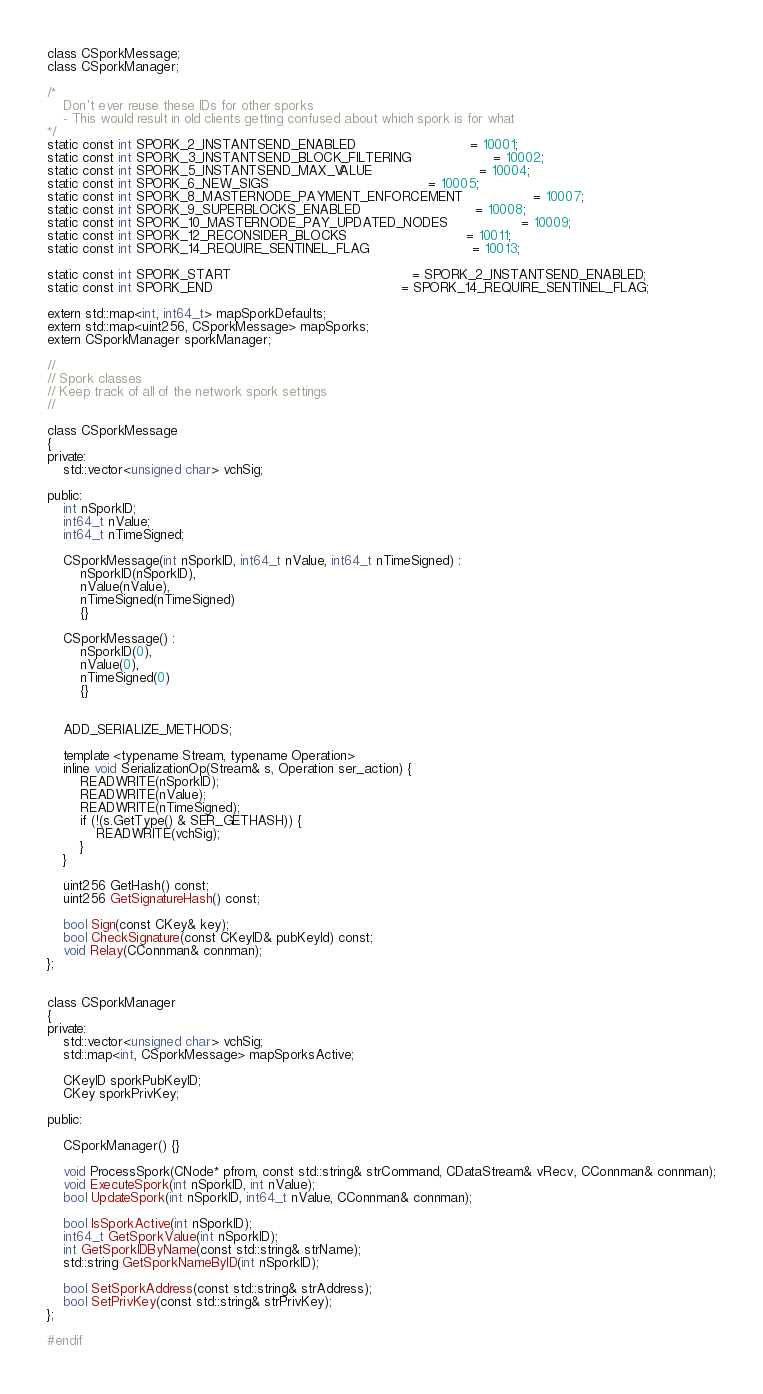<code> <loc_0><loc_0><loc_500><loc_500><_C_>class CSporkMessage;
class CSporkManager;

/*
    Don't ever reuse these IDs for other sporks
    - This would result in old clients getting confused about which spork is for what
*/
static const int SPORK_2_INSTANTSEND_ENABLED                            = 10001;
static const int SPORK_3_INSTANTSEND_BLOCK_FILTERING                    = 10002;
static const int SPORK_5_INSTANTSEND_MAX_VALUE                          = 10004;
static const int SPORK_6_NEW_SIGS                                       = 10005;
static const int SPORK_8_MASTERNODE_PAYMENT_ENFORCEMENT                 = 10007;
static const int SPORK_9_SUPERBLOCKS_ENABLED                            = 10008;
static const int SPORK_10_MASTERNODE_PAY_UPDATED_NODES                  = 10009;
static const int SPORK_12_RECONSIDER_BLOCKS                             = 10011;
static const int SPORK_14_REQUIRE_SENTINEL_FLAG                         = 10013;

static const int SPORK_START                                            = SPORK_2_INSTANTSEND_ENABLED;
static const int SPORK_END                                              = SPORK_14_REQUIRE_SENTINEL_FLAG;

extern std::map<int, int64_t> mapSporkDefaults;
extern std::map<uint256, CSporkMessage> mapSporks;
extern CSporkManager sporkManager;

//
// Spork classes
// Keep track of all of the network spork settings
//

class CSporkMessage
{
private:
    std::vector<unsigned char> vchSig;

public:
    int nSporkID;
    int64_t nValue;
    int64_t nTimeSigned;

    CSporkMessage(int nSporkID, int64_t nValue, int64_t nTimeSigned) :
        nSporkID(nSporkID),
        nValue(nValue),
        nTimeSigned(nTimeSigned)
        {}

    CSporkMessage() :
        nSporkID(0),
        nValue(0),
        nTimeSigned(0)
        {}


    ADD_SERIALIZE_METHODS;

    template <typename Stream, typename Operation>
    inline void SerializationOp(Stream& s, Operation ser_action) {
        READWRITE(nSporkID);
        READWRITE(nValue);
        READWRITE(nTimeSigned);
        if (!(s.GetType() & SER_GETHASH)) {
            READWRITE(vchSig);
        }
    }

    uint256 GetHash() const;
    uint256 GetSignatureHash() const;

    bool Sign(const CKey& key);
    bool CheckSignature(const CKeyID& pubKeyId) const;
    void Relay(CConnman& connman);
};


class CSporkManager
{
private:
    std::vector<unsigned char> vchSig;
    std::map<int, CSporkMessage> mapSporksActive;

    CKeyID sporkPubKeyID;
    CKey sporkPrivKey;

public:

    CSporkManager() {}

    void ProcessSpork(CNode* pfrom, const std::string& strCommand, CDataStream& vRecv, CConnman& connman);
    void ExecuteSpork(int nSporkID, int nValue);
    bool UpdateSpork(int nSporkID, int64_t nValue, CConnman& connman);

    bool IsSporkActive(int nSporkID);
    int64_t GetSporkValue(int nSporkID);
    int GetSporkIDByName(const std::string& strName);
    std::string GetSporkNameByID(int nSporkID);

    bool SetSporkAddress(const std::string& strAddress);
    bool SetPrivKey(const std::string& strPrivKey);
};

#endif
</code> 